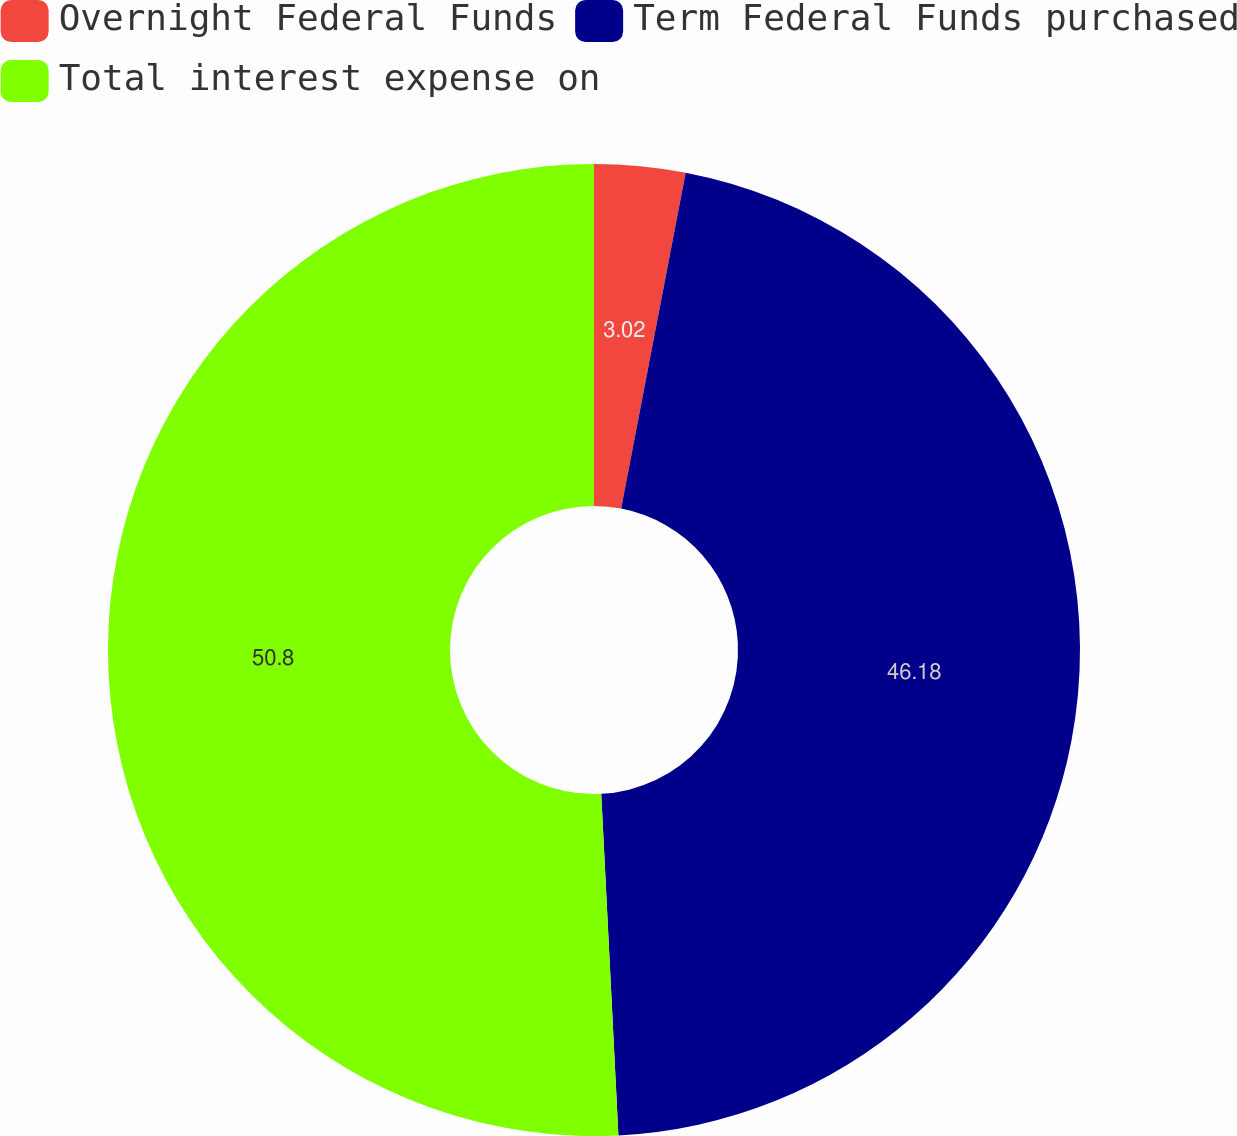<chart> <loc_0><loc_0><loc_500><loc_500><pie_chart><fcel>Overnight Federal Funds<fcel>Term Federal Funds purchased<fcel>Total interest expense on<nl><fcel>3.02%<fcel>46.18%<fcel>50.8%<nl></chart> 